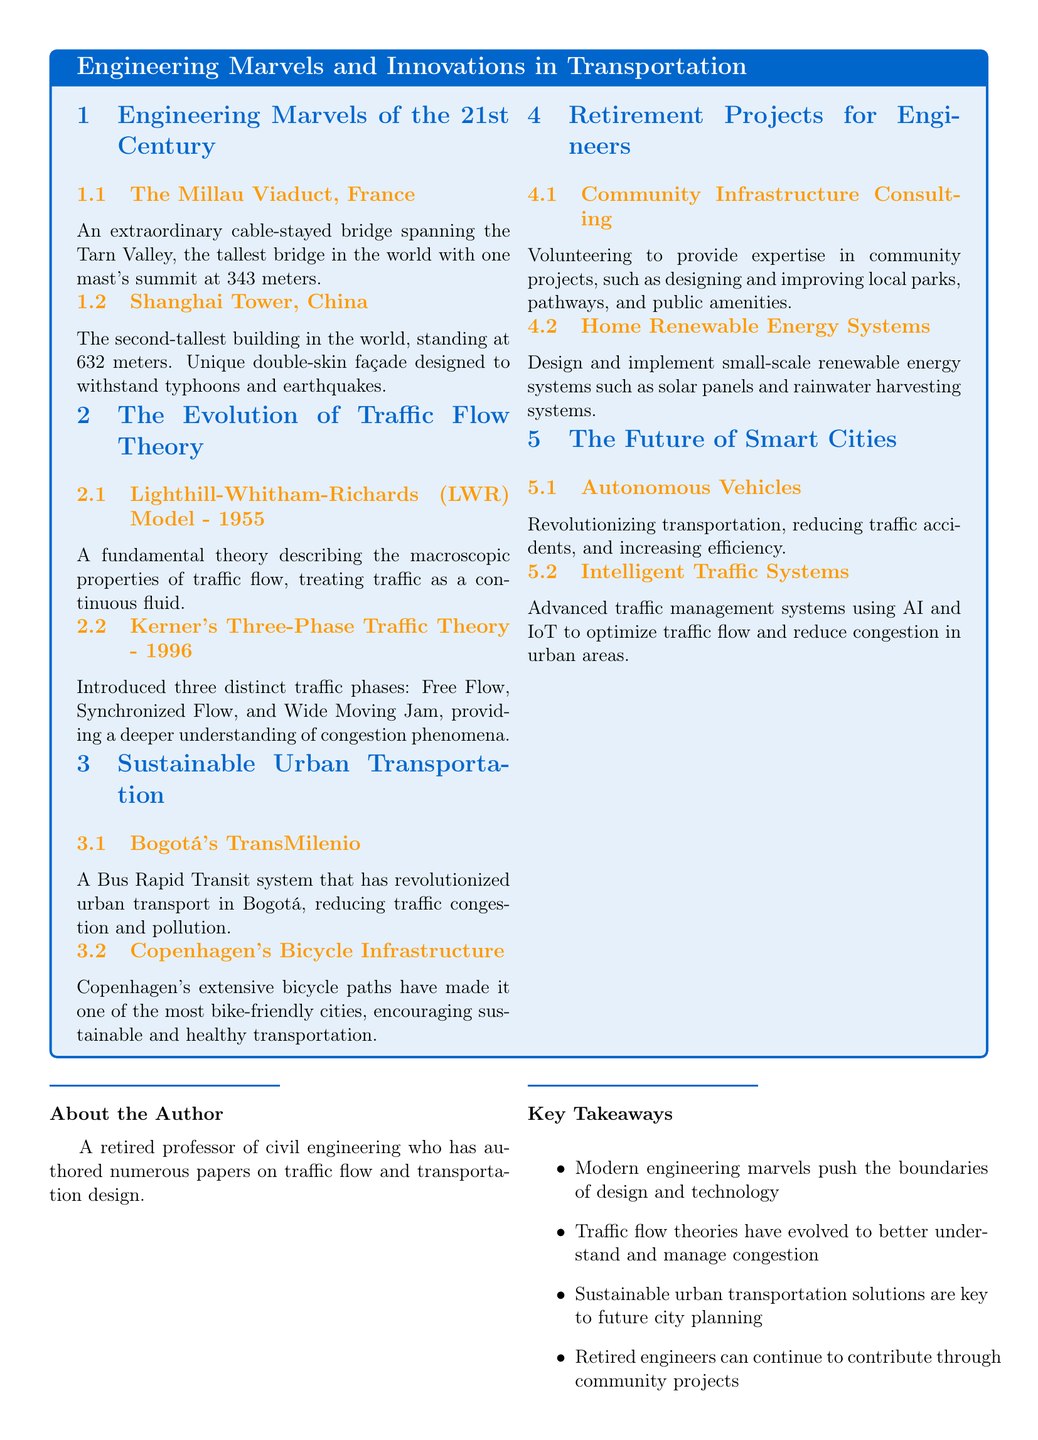What is the tallest bridge in the world? The Millau Viaduct in France is mentioned as the tallest bridge in the world, with one mast's summit at 343 meters.
Answer: The Millau Viaduct What year was the Kerner's Three-Phase Traffic Theory introduced? The document states that Kerner's Three-Phase Traffic Theory was introduced in 1996.
Answer: 1996 Which city has the TransMilenio system? The document mentions Bogotá as the city that has revolutionized urban transport through the TransMilenio system.
Answer: Bogotá What renewable energy system can retired engineers implement at home? The document includes designing and implementing small-scale renewable energy systems, specifically mentioning solar panels.
Answer: Solar panels What technology is reducing traffic accidents and increasing efficiency? The document discusses autonomous vehicles as a key technology that revolutionizes transportation by reducing traffic accidents and increasing efficiency.
Answer: Autonomous Vehicles What feature of Copenhagen makes it bike-friendly? The extensive bicycle paths mentioned in the document are the key feature that makes Copenhagen one of the most bike-friendly cities.
Answer: Bicycle paths What is a significant traffic flow theory discussed in the document? The Lighthill-Whitham-Richards (LWR) Model from 1955 is highlighted as a fundamental theory in traffic flow.
Answer: LWR Model What type of community project can retired engineers engage in? The document suggests volunteering to provide expertise in designing and improving local parks as a community project for retired engineers.
Answer: Community projects What is a key takeaway regarding sustainable urban transportation? The document emphasizes that sustainable urban transportation solutions are integral to future city planning.
Answer: Future city planning 